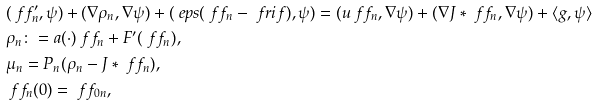Convert formula to latex. <formula><loc_0><loc_0><loc_500><loc_500>& ( \ f f _ { n } ^ { \prime } , \psi ) + ( \nabla \rho _ { n } , \nabla \psi ) + ( \ e p s ( \ f f _ { n } - \ f r i f ) , \psi ) = ( u \ f f _ { n } , \nabla \psi ) + ( \nabla J \ast \ f f _ { n } , \nabla \psi ) + \langle g , \psi \rangle \\ & \rho _ { n } \colon = a ( \cdot ) \ f f _ { n } + F ^ { \prime } ( \ f f _ { n } ) , \\ & \mu _ { n } = P _ { n } ( \rho _ { n } - J \ast \ f f _ { n } ) , \\ & \ f f _ { n } ( 0 ) = \ f f _ { 0 n } ,</formula> 